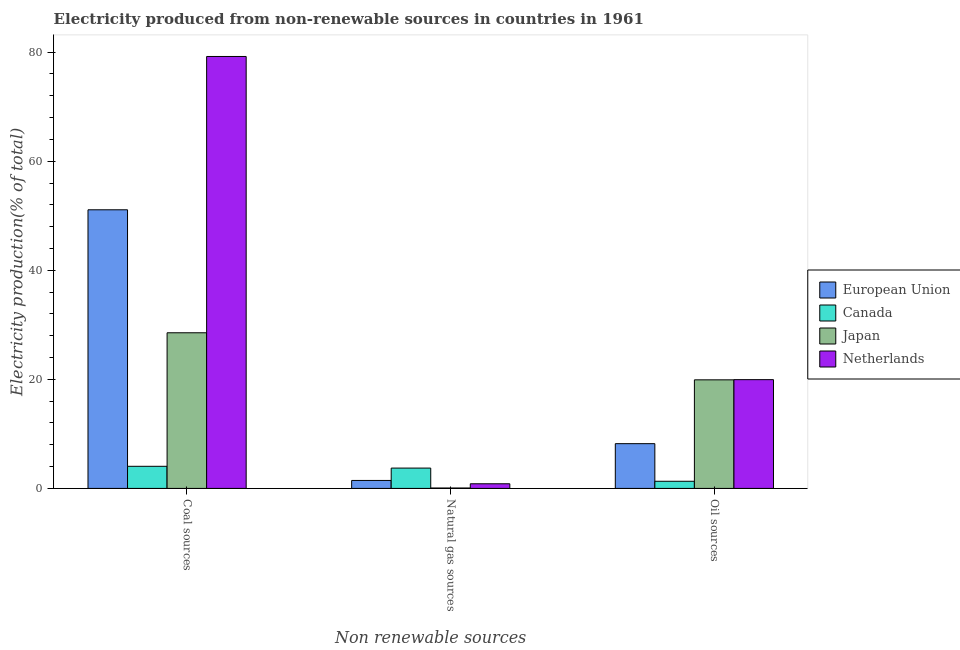How many different coloured bars are there?
Your response must be concise. 4. How many bars are there on the 3rd tick from the right?
Ensure brevity in your answer.  4. What is the label of the 1st group of bars from the left?
Your answer should be very brief. Coal sources. What is the percentage of electricity produced by coal in Japan?
Offer a terse response. 28.54. Across all countries, what is the maximum percentage of electricity produced by natural gas?
Make the answer very short. 3.73. Across all countries, what is the minimum percentage of electricity produced by natural gas?
Offer a terse response. 0.08. In which country was the percentage of electricity produced by coal maximum?
Make the answer very short. Netherlands. In which country was the percentage of electricity produced by oil sources minimum?
Offer a very short reply. Canada. What is the total percentage of electricity produced by oil sources in the graph?
Provide a succinct answer. 49.37. What is the difference between the percentage of electricity produced by natural gas in Netherlands and that in Canada?
Your answer should be very brief. -2.88. What is the difference between the percentage of electricity produced by coal in Japan and the percentage of electricity produced by oil sources in Netherlands?
Make the answer very short. 8.59. What is the average percentage of electricity produced by oil sources per country?
Provide a succinct answer. 12.34. What is the difference between the percentage of electricity produced by natural gas and percentage of electricity produced by oil sources in Netherlands?
Give a very brief answer. -19.09. In how many countries, is the percentage of electricity produced by oil sources greater than 72 %?
Provide a short and direct response. 0. What is the ratio of the percentage of electricity produced by natural gas in Canada to that in Netherlands?
Keep it short and to the point. 4.38. Is the difference between the percentage of electricity produced by natural gas in Netherlands and Canada greater than the difference between the percentage of electricity produced by oil sources in Netherlands and Canada?
Provide a succinct answer. No. What is the difference between the highest and the second highest percentage of electricity produced by oil sources?
Your response must be concise. 0.04. What is the difference between the highest and the lowest percentage of electricity produced by oil sources?
Keep it short and to the point. 18.64. What does the 2nd bar from the left in Natural gas sources represents?
Provide a succinct answer. Canada. Is it the case that in every country, the sum of the percentage of electricity produced by coal and percentage of electricity produced by natural gas is greater than the percentage of electricity produced by oil sources?
Provide a succinct answer. Yes. Are all the bars in the graph horizontal?
Your answer should be very brief. No. Are the values on the major ticks of Y-axis written in scientific E-notation?
Your response must be concise. No. How are the legend labels stacked?
Your answer should be very brief. Vertical. What is the title of the graph?
Provide a succinct answer. Electricity produced from non-renewable sources in countries in 1961. What is the label or title of the X-axis?
Your answer should be compact. Non renewable sources. What is the label or title of the Y-axis?
Provide a short and direct response. Electricity production(% of total). What is the Electricity production(% of total) in European Union in Coal sources?
Your answer should be very brief. 51.09. What is the Electricity production(% of total) in Canada in Coal sources?
Provide a succinct answer. 4.05. What is the Electricity production(% of total) in Japan in Coal sources?
Keep it short and to the point. 28.54. What is the Electricity production(% of total) of Netherlands in Coal sources?
Offer a very short reply. 79.2. What is the Electricity production(% of total) of European Union in Natural gas sources?
Provide a short and direct response. 1.46. What is the Electricity production(% of total) in Canada in Natural gas sources?
Your answer should be very brief. 3.73. What is the Electricity production(% of total) in Japan in Natural gas sources?
Keep it short and to the point. 0.08. What is the Electricity production(% of total) of Netherlands in Natural gas sources?
Keep it short and to the point. 0.85. What is the Electricity production(% of total) in European Union in Oil sources?
Provide a succinct answer. 8.21. What is the Electricity production(% of total) of Canada in Oil sources?
Your answer should be very brief. 1.31. What is the Electricity production(% of total) in Japan in Oil sources?
Make the answer very short. 19.91. What is the Electricity production(% of total) in Netherlands in Oil sources?
Make the answer very short. 19.94. Across all Non renewable sources, what is the maximum Electricity production(% of total) in European Union?
Give a very brief answer. 51.09. Across all Non renewable sources, what is the maximum Electricity production(% of total) of Canada?
Provide a succinct answer. 4.05. Across all Non renewable sources, what is the maximum Electricity production(% of total) of Japan?
Your answer should be compact. 28.54. Across all Non renewable sources, what is the maximum Electricity production(% of total) of Netherlands?
Give a very brief answer. 79.2. Across all Non renewable sources, what is the minimum Electricity production(% of total) of European Union?
Give a very brief answer. 1.46. Across all Non renewable sources, what is the minimum Electricity production(% of total) of Canada?
Ensure brevity in your answer.  1.31. Across all Non renewable sources, what is the minimum Electricity production(% of total) of Japan?
Make the answer very short. 0.08. Across all Non renewable sources, what is the minimum Electricity production(% of total) of Netherlands?
Offer a terse response. 0.85. What is the total Electricity production(% of total) of European Union in the graph?
Offer a very short reply. 60.76. What is the total Electricity production(% of total) of Canada in the graph?
Your answer should be very brief. 9.09. What is the total Electricity production(% of total) of Japan in the graph?
Your answer should be very brief. 48.52. What is the total Electricity production(% of total) in Netherlands in the graph?
Keep it short and to the point. 100. What is the difference between the Electricity production(% of total) in European Union in Coal sources and that in Natural gas sources?
Offer a terse response. 49.63. What is the difference between the Electricity production(% of total) of Canada in Coal sources and that in Natural gas sources?
Make the answer very short. 0.33. What is the difference between the Electricity production(% of total) of Japan in Coal sources and that in Natural gas sources?
Offer a terse response. 28.46. What is the difference between the Electricity production(% of total) in Netherlands in Coal sources and that in Natural gas sources?
Give a very brief answer. 78.35. What is the difference between the Electricity production(% of total) in European Union in Coal sources and that in Oil sources?
Provide a succinct answer. 42.89. What is the difference between the Electricity production(% of total) of Canada in Coal sources and that in Oil sources?
Give a very brief answer. 2.75. What is the difference between the Electricity production(% of total) in Japan in Coal sources and that in Oil sources?
Your answer should be compact. 8.63. What is the difference between the Electricity production(% of total) of Netherlands in Coal sources and that in Oil sources?
Keep it short and to the point. 59.26. What is the difference between the Electricity production(% of total) in European Union in Natural gas sources and that in Oil sources?
Offer a terse response. -6.74. What is the difference between the Electricity production(% of total) of Canada in Natural gas sources and that in Oil sources?
Offer a very short reply. 2.42. What is the difference between the Electricity production(% of total) of Japan in Natural gas sources and that in Oil sources?
Provide a short and direct response. -19.83. What is the difference between the Electricity production(% of total) of Netherlands in Natural gas sources and that in Oil sources?
Offer a terse response. -19.09. What is the difference between the Electricity production(% of total) of European Union in Coal sources and the Electricity production(% of total) of Canada in Natural gas sources?
Your response must be concise. 47.36. What is the difference between the Electricity production(% of total) of European Union in Coal sources and the Electricity production(% of total) of Japan in Natural gas sources?
Your answer should be compact. 51.02. What is the difference between the Electricity production(% of total) in European Union in Coal sources and the Electricity production(% of total) in Netherlands in Natural gas sources?
Your response must be concise. 50.24. What is the difference between the Electricity production(% of total) in Canada in Coal sources and the Electricity production(% of total) in Japan in Natural gas sources?
Offer a terse response. 3.98. What is the difference between the Electricity production(% of total) of Canada in Coal sources and the Electricity production(% of total) of Netherlands in Natural gas sources?
Provide a short and direct response. 3.2. What is the difference between the Electricity production(% of total) in Japan in Coal sources and the Electricity production(% of total) in Netherlands in Natural gas sources?
Offer a very short reply. 27.69. What is the difference between the Electricity production(% of total) in European Union in Coal sources and the Electricity production(% of total) in Canada in Oil sources?
Offer a very short reply. 49.78. What is the difference between the Electricity production(% of total) in European Union in Coal sources and the Electricity production(% of total) in Japan in Oil sources?
Offer a terse response. 31.18. What is the difference between the Electricity production(% of total) of European Union in Coal sources and the Electricity production(% of total) of Netherlands in Oil sources?
Ensure brevity in your answer.  31.15. What is the difference between the Electricity production(% of total) of Canada in Coal sources and the Electricity production(% of total) of Japan in Oil sources?
Provide a succinct answer. -15.86. What is the difference between the Electricity production(% of total) in Canada in Coal sources and the Electricity production(% of total) in Netherlands in Oil sources?
Ensure brevity in your answer.  -15.89. What is the difference between the Electricity production(% of total) of Japan in Coal sources and the Electricity production(% of total) of Netherlands in Oil sources?
Offer a very short reply. 8.59. What is the difference between the Electricity production(% of total) of European Union in Natural gas sources and the Electricity production(% of total) of Canada in Oil sources?
Ensure brevity in your answer.  0.15. What is the difference between the Electricity production(% of total) of European Union in Natural gas sources and the Electricity production(% of total) of Japan in Oil sources?
Make the answer very short. -18.45. What is the difference between the Electricity production(% of total) of European Union in Natural gas sources and the Electricity production(% of total) of Netherlands in Oil sources?
Keep it short and to the point. -18.48. What is the difference between the Electricity production(% of total) in Canada in Natural gas sources and the Electricity production(% of total) in Japan in Oil sources?
Offer a terse response. -16.18. What is the difference between the Electricity production(% of total) in Canada in Natural gas sources and the Electricity production(% of total) in Netherlands in Oil sources?
Your answer should be very brief. -16.22. What is the difference between the Electricity production(% of total) in Japan in Natural gas sources and the Electricity production(% of total) in Netherlands in Oil sources?
Your response must be concise. -19.87. What is the average Electricity production(% of total) of European Union per Non renewable sources?
Your answer should be very brief. 20.25. What is the average Electricity production(% of total) of Canada per Non renewable sources?
Offer a very short reply. 3.03. What is the average Electricity production(% of total) in Japan per Non renewable sources?
Keep it short and to the point. 16.17. What is the average Electricity production(% of total) of Netherlands per Non renewable sources?
Offer a very short reply. 33.33. What is the difference between the Electricity production(% of total) of European Union and Electricity production(% of total) of Canada in Coal sources?
Provide a short and direct response. 47.04. What is the difference between the Electricity production(% of total) of European Union and Electricity production(% of total) of Japan in Coal sources?
Ensure brevity in your answer.  22.55. What is the difference between the Electricity production(% of total) of European Union and Electricity production(% of total) of Netherlands in Coal sources?
Make the answer very short. -28.11. What is the difference between the Electricity production(% of total) of Canada and Electricity production(% of total) of Japan in Coal sources?
Offer a terse response. -24.48. What is the difference between the Electricity production(% of total) of Canada and Electricity production(% of total) of Netherlands in Coal sources?
Keep it short and to the point. -75.15. What is the difference between the Electricity production(% of total) in Japan and Electricity production(% of total) in Netherlands in Coal sources?
Keep it short and to the point. -50.67. What is the difference between the Electricity production(% of total) of European Union and Electricity production(% of total) of Canada in Natural gas sources?
Offer a terse response. -2.27. What is the difference between the Electricity production(% of total) in European Union and Electricity production(% of total) in Japan in Natural gas sources?
Your answer should be very brief. 1.39. What is the difference between the Electricity production(% of total) in European Union and Electricity production(% of total) in Netherlands in Natural gas sources?
Ensure brevity in your answer.  0.61. What is the difference between the Electricity production(% of total) in Canada and Electricity production(% of total) in Japan in Natural gas sources?
Your answer should be very brief. 3.65. What is the difference between the Electricity production(% of total) of Canada and Electricity production(% of total) of Netherlands in Natural gas sources?
Provide a short and direct response. 2.88. What is the difference between the Electricity production(% of total) in Japan and Electricity production(% of total) in Netherlands in Natural gas sources?
Ensure brevity in your answer.  -0.78. What is the difference between the Electricity production(% of total) in European Union and Electricity production(% of total) in Canada in Oil sources?
Offer a very short reply. 6.9. What is the difference between the Electricity production(% of total) of European Union and Electricity production(% of total) of Japan in Oil sources?
Give a very brief answer. -11.7. What is the difference between the Electricity production(% of total) in European Union and Electricity production(% of total) in Netherlands in Oil sources?
Offer a very short reply. -11.74. What is the difference between the Electricity production(% of total) of Canada and Electricity production(% of total) of Japan in Oil sources?
Offer a terse response. -18.6. What is the difference between the Electricity production(% of total) in Canada and Electricity production(% of total) in Netherlands in Oil sources?
Keep it short and to the point. -18.64. What is the difference between the Electricity production(% of total) in Japan and Electricity production(% of total) in Netherlands in Oil sources?
Offer a very short reply. -0.04. What is the ratio of the Electricity production(% of total) in European Union in Coal sources to that in Natural gas sources?
Offer a terse response. 34.95. What is the ratio of the Electricity production(% of total) in Canada in Coal sources to that in Natural gas sources?
Ensure brevity in your answer.  1.09. What is the ratio of the Electricity production(% of total) in Japan in Coal sources to that in Natural gas sources?
Keep it short and to the point. 377. What is the ratio of the Electricity production(% of total) of Netherlands in Coal sources to that in Natural gas sources?
Keep it short and to the point. 93.06. What is the ratio of the Electricity production(% of total) in European Union in Coal sources to that in Oil sources?
Give a very brief answer. 6.23. What is the ratio of the Electricity production(% of total) of Canada in Coal sources to that in Oil sources?
Your answer should be compact. 3.1. What is the ratio of the Electricity production(% of total) in Japan in Coal sources to that in Oil sources?
Offer a very short reply. 1.43. What is the ratio of the Electricity production(% of total) in Netherlands in Coal sources to that in Oil sources?
Your response must be concise. 3.97. What is the ratio of the Electricity production(% of total) in European Union in Natural gas sources to that in Oil sources?
Ensure brevity in your answer.  0.18. What is the ratio of the Electricity production(% of total) of Canada in Natural gas sources to that in Oil sources?
Give a very brief answer. 2.85. What is the ratio of the Electricity production(% of total) in Japan in Natural gas sources to that in Oil sources?
Your response must be concise. 0. What is the ratio of the Electricity production(% of total) of Netherlands in Natural gas sources to that in Oil sources?
Offer a terse response. 0.04. What is the difference between the highest and the second highest Electricity production(% of total) in European Union?
Offer a terse response. 42.89. What is the difference between the highest and the second highest Electricity production(% of total) in Canada?
Give a very brief answer. 0.33. What is the difference between the highest and the second highest Electricity production(% of total) in Japan?
Ensure brevity in your answer.  8.63. What is the difference between the highest and the second highest Electricity production(% of total) of Netherlands?
Keep it short and to the point. 59.26. What is the difference between the highest and the lowest Electricity production(% of total) of European Union?
Your answer should be very brief. 49.63. What is the difference between the highest and the lowest Electricity production(% of total) in Canada?
Keep it short and to the point. 2.75. What is the difference between the highest and the lowest Electricity production(% of total) of Japan?
Provide a succinct answer. 28.46. What is the difference between the highest and the lowest Electricity production(% of total) of Netherlands?
Give a very brief answer. 78.35. 